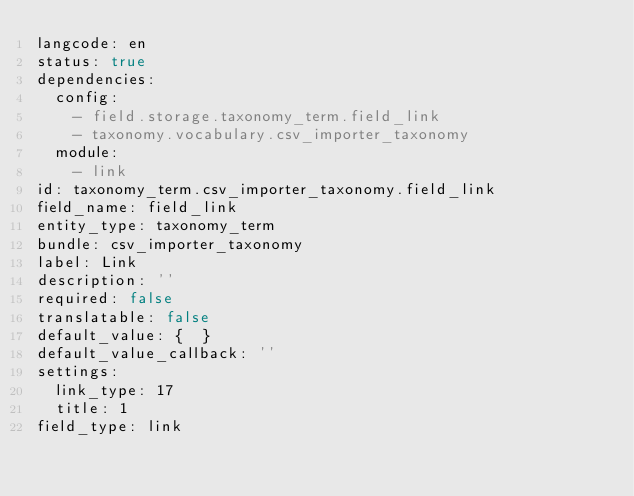<code> <loc_0><loc_0><loc_500><loc_500><_YAML_>langcode: en
status: true
dependencies:
  config:
    - field.storage.taxonomy_term.field_link
    - taxonomy.vocabulary.csv_importer_taxonomy
  module:
    - link
id: taxonomy_term.csv_importer_taxonomy.field_link
field_name: field_link
entity_type: taxonomy_term
bundle: csv_importer_taxonomy
label: Link
description: ''
required: false
translatable: false
default_value: {  }
default_value_callback: ''
settings:
  link_type: 17
  title: 1
field_type: link
</code> 